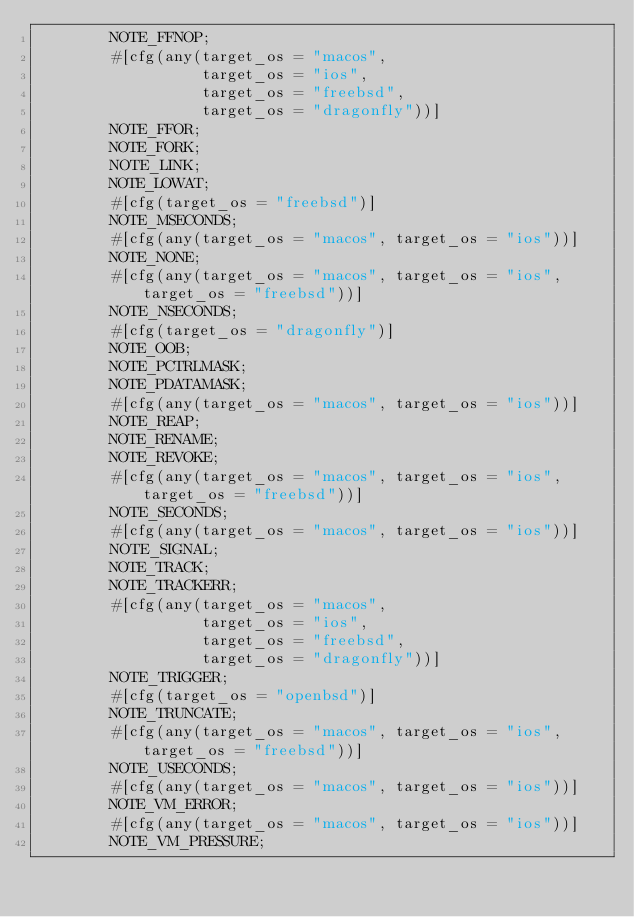<code> <loc_0><loc_0><loc_500><loc_500><_Rust_>        NOTE_FFNOP;
        #[cfg(any(target_os = "macos",
                  target_os = "ios",
                  target_os = "freebsd",
                  target_os = "dragonfly"))]
        NOTE_FFOR;
        NOTE_FORK;
        NOTE_LINK;
        NOTE_LOWAT;
        #[cfg(target_os = "freebsd")]
        NOTE_MSECONDS;
        #[cfg(any(target_os = "macos", target_os = "ios"))]
        NOTE_NONE;
        #[cfg(any(target_os = "macos", target_os = "ios", target_os = "freebsd"))]
        NOTE_NSECONDS;
        #[cfg(target_os = "dragonfly")]
        NOTE_OOB;
        NOTE_PCTRLMASK;
        NOTE_PDATAMASK;
        #[cfg(any(target_os = "macos", target_os = "ios"))]
        NOTE_REAP;
        NOTE_RENAME;
        NOTE_REVOKE;
        #[cfg(any(target_os = "macos", target_os = "ios", target_os = "freebsd"))]
        NOTE_SECONDS;
        #[cfg(any(target_os = "macos", target_os = "ios"))]
        NOTE_SIGNAL;
        NOTE_TRACK;
        NOTE_TRACKERR;
        #[cfg(any(target_os = "macos",
                  target_os = "ios",
                  target_os = "freebsd",
                  target_os = "dragonfly"))]
        NOTE_TRIGGER;
        #[cfg(target_os = "openbsd")]
        NOTE_TRUNCATE;
        #[cfg(any(target_os = "macos", target_os = "ios", target_os = "freebsd"))]
        NOTE_USECONDS;
        #[cfg(any(target_os = "macos", target_os = "ios"))]
        NOTE_VM_ERROR;
        #[cfg(any(target_os = "macos", target_os = "ios"))]
        NOTE_VM_PRESSURE;</code> 